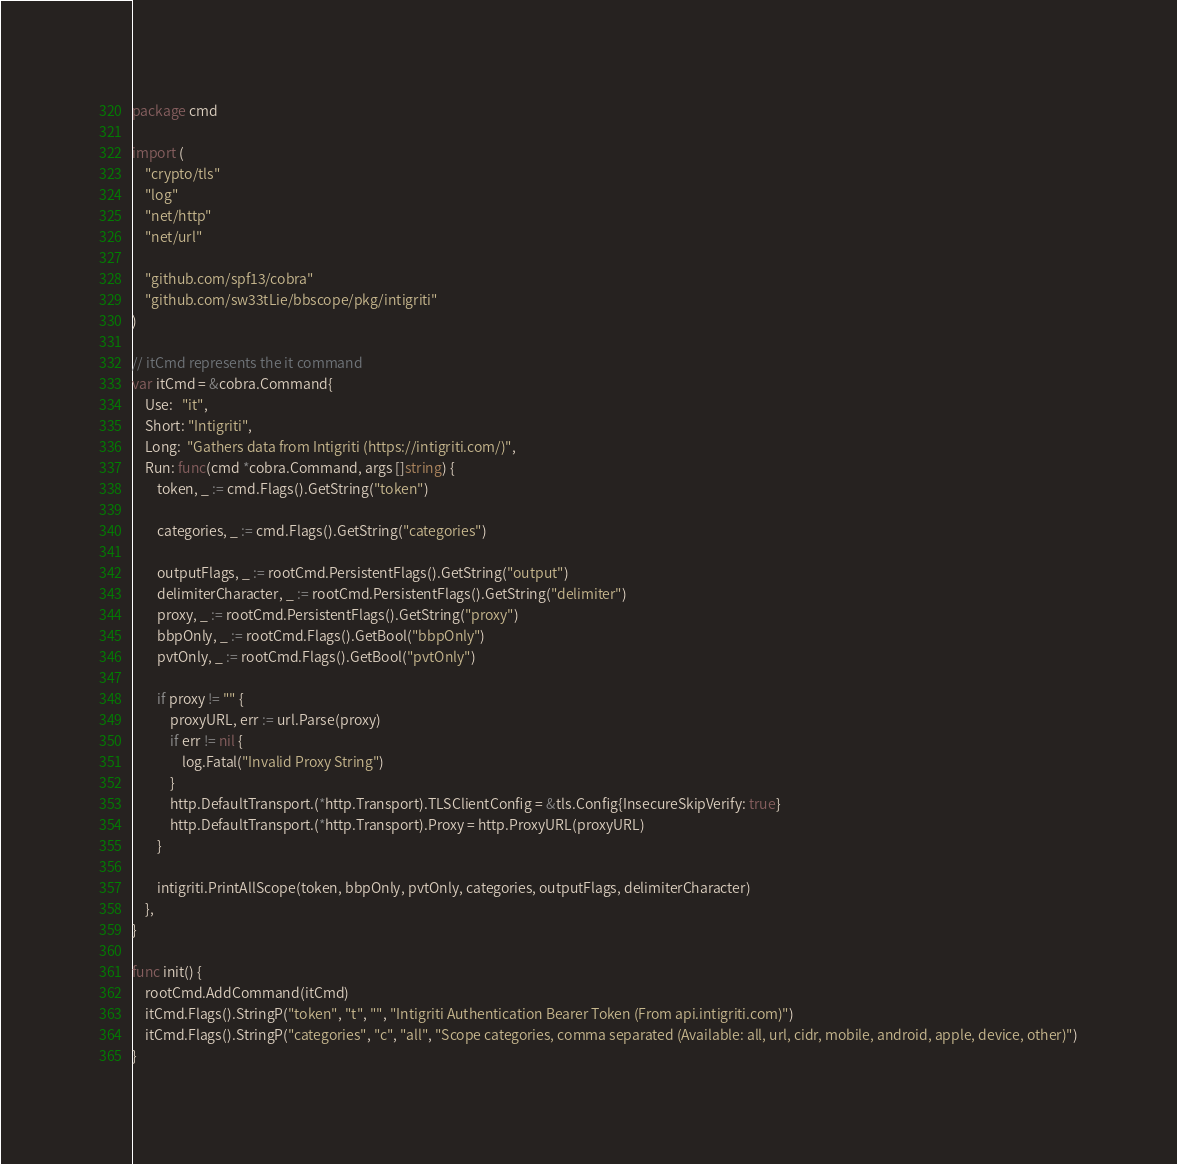Convert code to text. <code><loc_0><loc_0><loc_500><loc_500><_Go_>package cmd

import (
	"crypto/tls"
	"log"
	"net/http"
	"net/url"

	"github.com/spf13/cobra"
	"github.com/sw33tLie/bbscope/pkg/intigriti"
)

// itCmd represents the it command
var itCmd = &cobra.Command{
	Use:   "it",
	Short: "Intigriti",
	Long:  "Gathers data from Intigriti (https://intigriti.com/)",
	Run: func(cmd *cobra.Command, args []string) {
		token, _ := cmd.Flags().GetString("token")

		categories, _ := cmd.Flags().GetString("categories")

		outputFlags, _ := rootCmd.PersistentFlags().GetString("output")
		delimiterCharacter, _ := rootCmd.PersistentFlags().GetString("delimiter")
		proxy, _ := rootCmd.PersistentFlags().GetString("proxy")
		bbpOnly, _ := rootCmd.Flags().GetBool("bbpOnly")
		pvtOnly, _ := rootCmd.Flags().GetBool("pvtOnly")

		if proxy != "" {
			proxyURL, err := url.Parse(proxy)
			if err != nil {
				log.Fatal("Invalid Proxy String")
			}
			http.DefaultTransport.(*http.Transport).TLSClientConfig = &tls.Config{InsecureSkipVerify: true}
			http.DefaultTransport.(*http.Transport).Proxy = http.ProxyURL(proxyURL)
		}

		intigriti.PrintAllScope(token, bbpOnly, pvtOnly, categories, outputFlags, delimiterCharacter)
	},
}

func init() {
	rootCmd.AddCommand(itCmd)
	itCmd.Flags().StringP("token", "t", "", "Intigriti Authentication Bearer Token (From api.intigriti.com)")
	itCmd.Flags().StringP("categories", "c", "all", "Scope categories, comma separated (Available: all, url, cidr, mobile, android, apple, device, other)")
}
</code> 